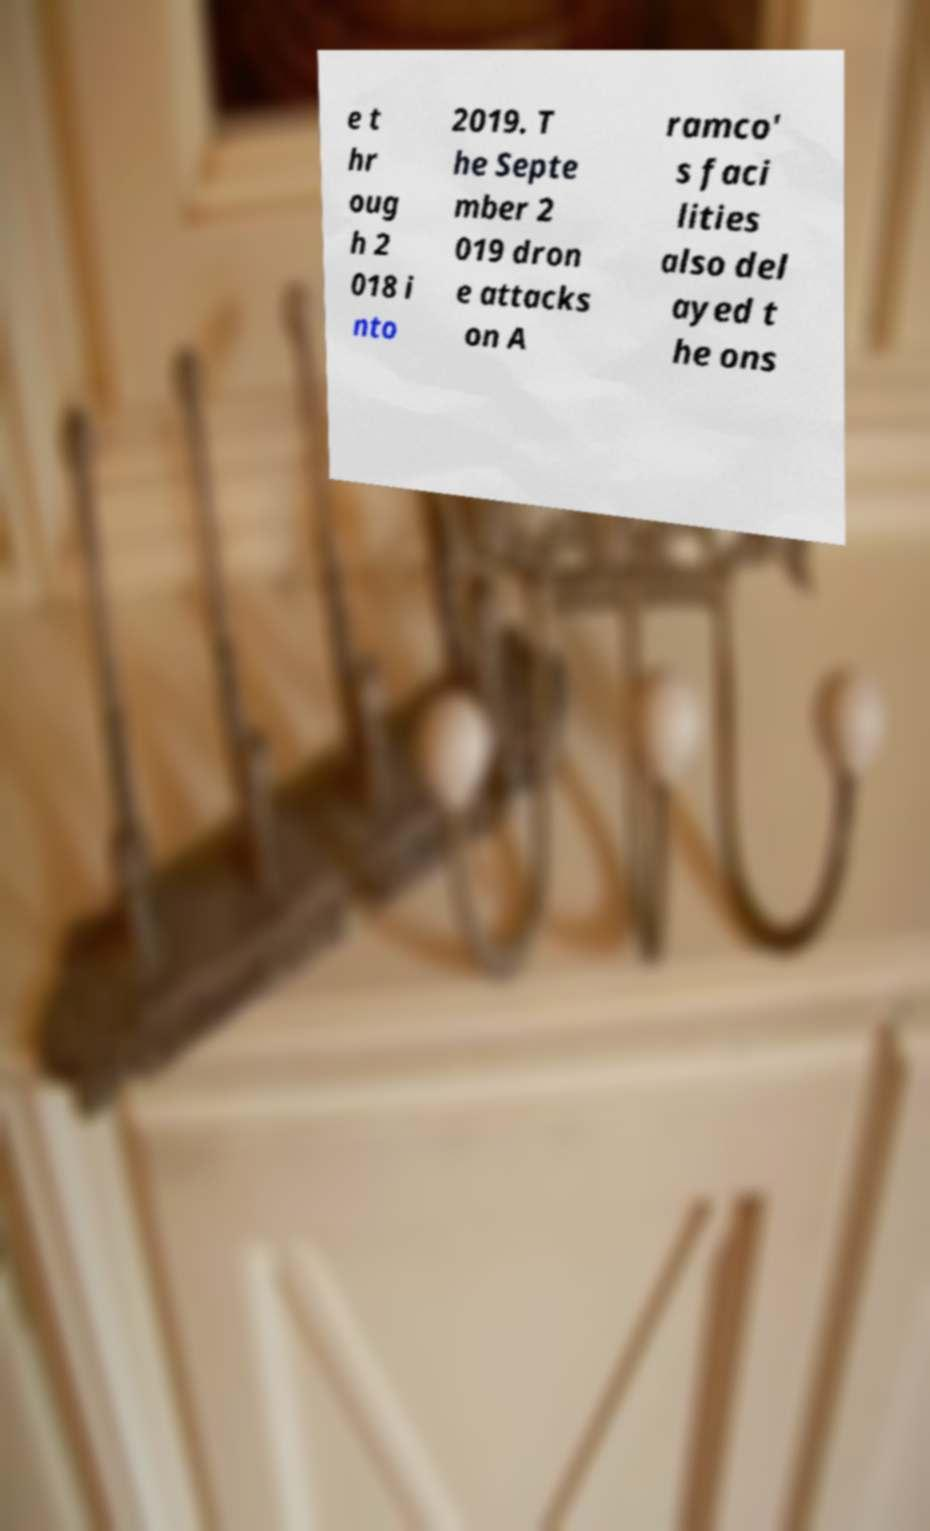Can you read and provide the text displayed in the image?This photo seems to have some interesting text. Can you extract and type it out for me? e t hr oug h 2 018 i nto 2019. T he Septe mber 2 019 dron e attacks on A ramco' s faci lities also del ayed t he ons 